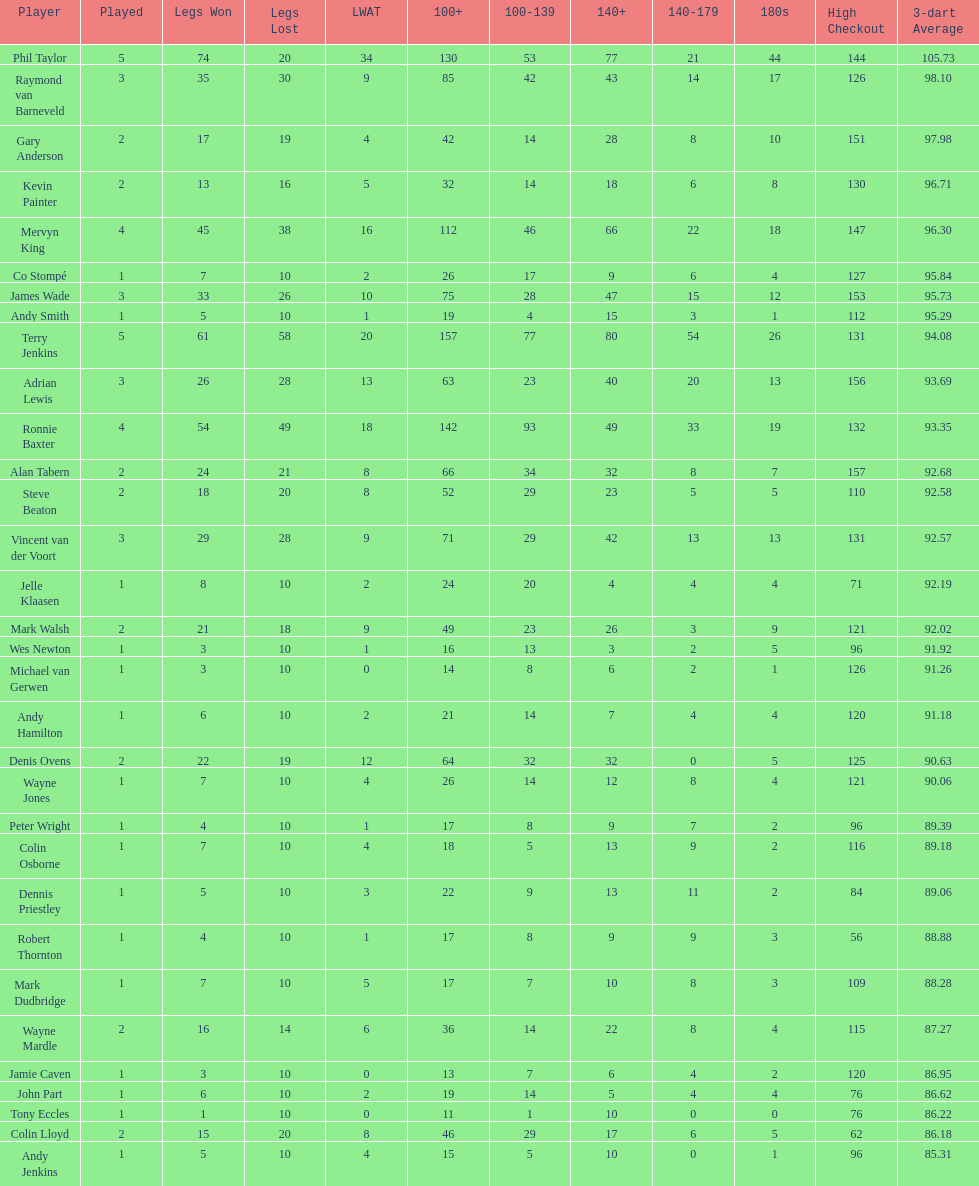Who won the highest number of legs in the 2009 world matchplay? Phil Taylor. 